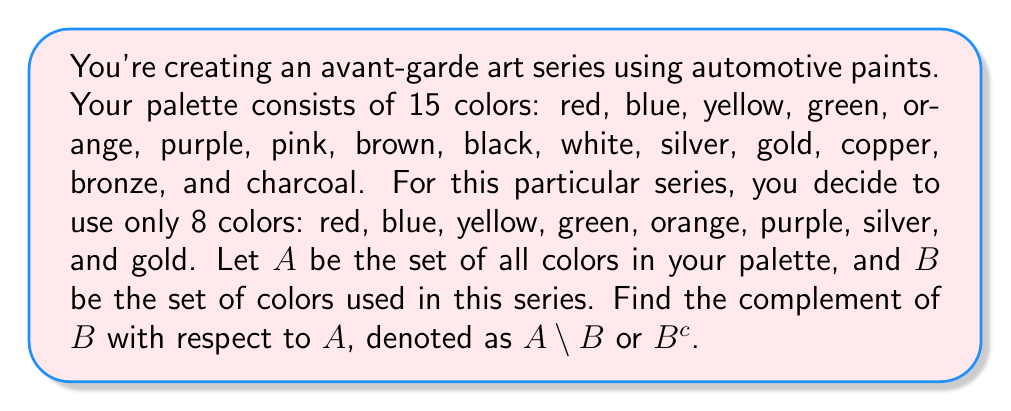What is the answer to this math problem? To solve this problem, we need to follow these steps:

1) First, let's define our sets:
   $A = \{$ red, blue, yellow, green, orange, purple, pink, brown, black, white, silver, gold, copper, bronze, charcoal $\}$
   $B = \{$ red, blue, yellow, green, orange, purple, silver, gold $\}$

2) The complement of $B$ with respect to $A$, denoted as $A \setminus B$ or $B^c$, is the set of all elements in $A$ that are not in $B$.

3) To find this, we need to identify all the colors in $A$ that are not used in the art series (not in $B$).

4) We can do this by listing all the colors in $A$ and crossing out the ones that appear in $B$:

   red, blue, yellow, green, orange, purple, ~~pink~~, ~~brown~~, ~~black~~, ~~white~~, silver, gold, ~~copper~~, ~~bronze~~, ~~charcoal~~

5) The remaining colors (those not crossed out) form the complement set.

Therefore, $A \setminus B = \{$ pink, brown, black, white, copper, bronze, charcoal $\}$

This set represents all the colors in your palette that you didn't use for this particular art series.
Answer: $A \setminus B = \{$ pink, brown, black, white, copper, bronze, charcoal $\}$ 